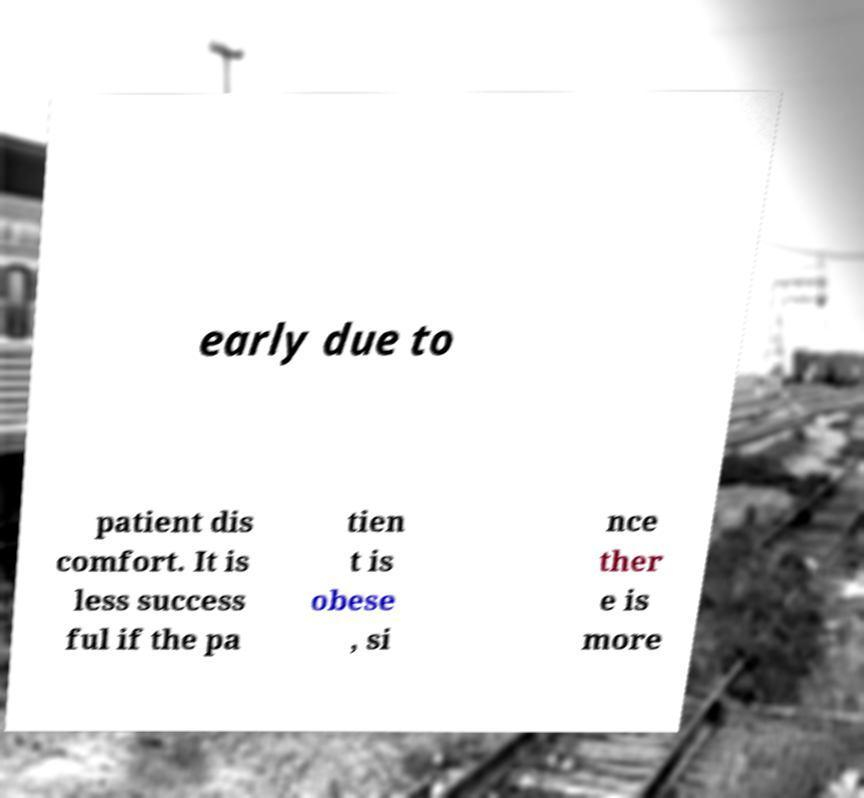Can you read and provide the text displayed in the image?This photo seems to have some interesting text. Can you extract and type it out for me? early due to patient dis comfort. It is less success ful if the pa tien t is obese , si nce ther e is more 